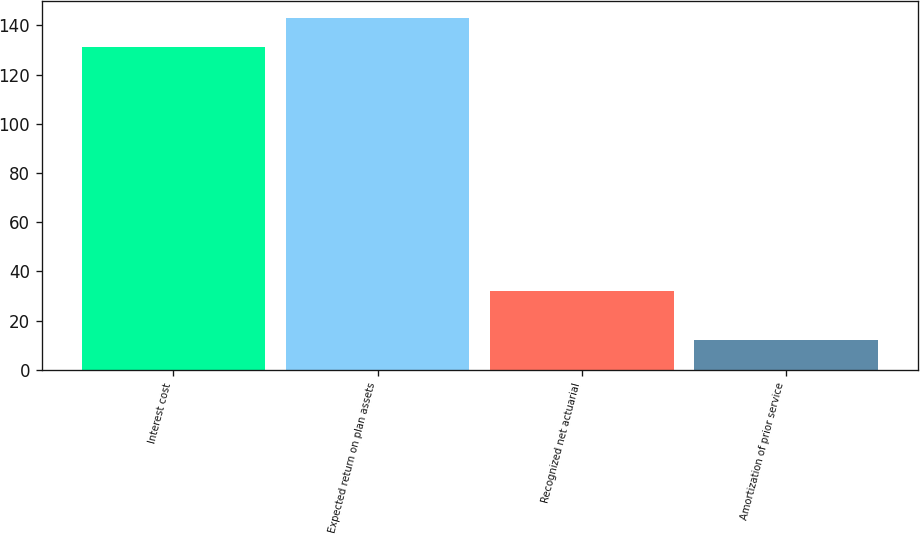Convert chart to OTSL. <chart><loc_0><loc_0><loc_500><loc_500><bar_chart><fcel>Interest cost<fcel>Expected return on plan assets<fcel>Recognized net actuarial<fcel>Amortization of prior service<nl><fcel>131<fcel>142.9<fcel>32<fcel>12<nl></chart> 